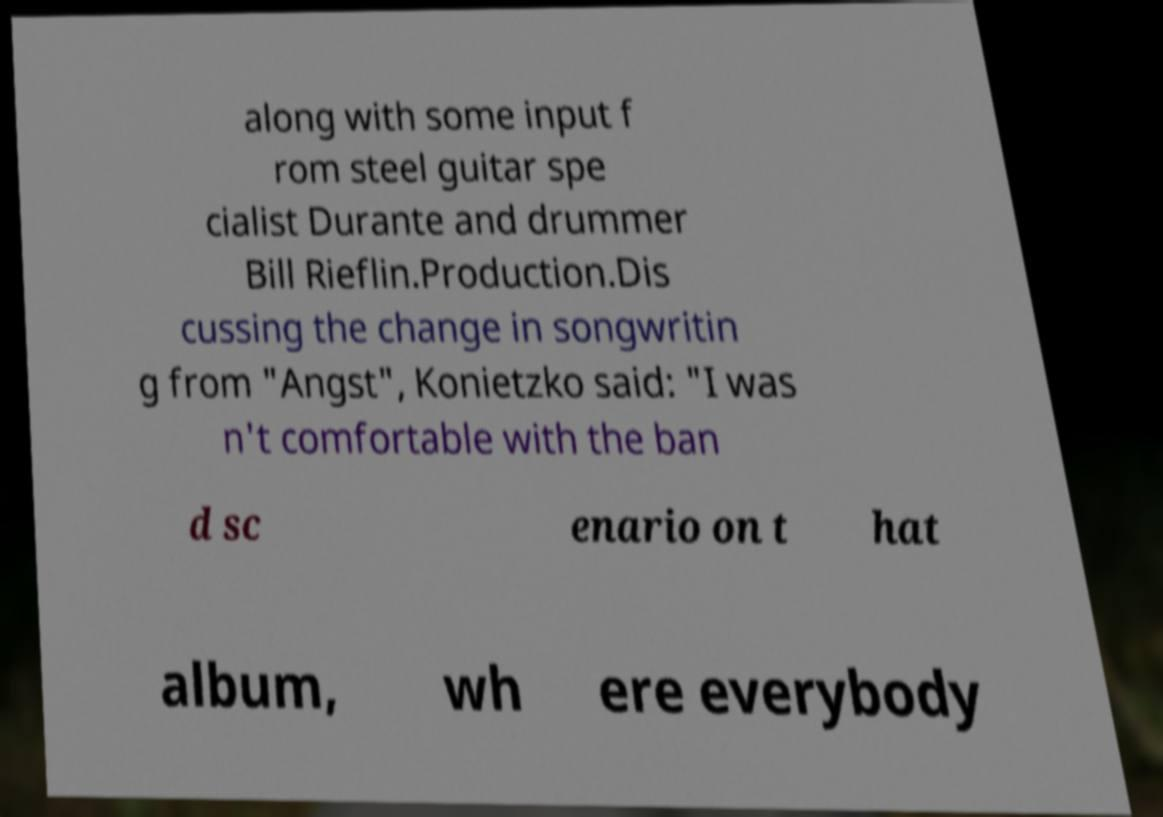I need the written content from this picture converted into text. Can you do that? along with some input f rom steel guitar spe cialist Durante and drummer Bill Rieflin.Production.Dis cussing the change in songwritin g from "Angst", Konietzko said: "I was n't comfortable with the ban d sc enario on t hat album, wh ere everybody 